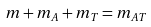Convert formula to latex. <formula><loc_0><loc_0><loc_500><loc_500>m + m _ { A } + m _ { T } = m _ { A T }</formula> 